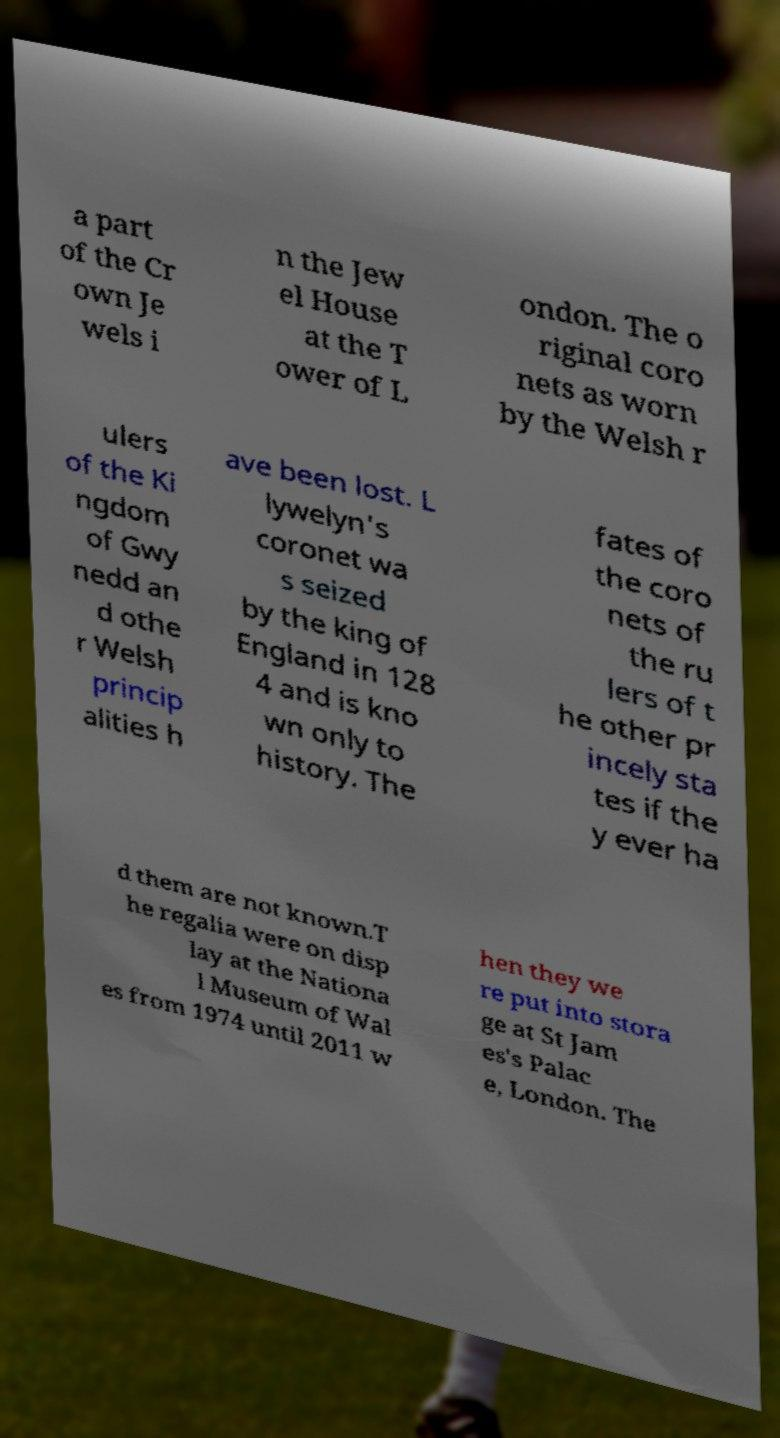There's text embedded in this image that I need extracted. Can you transcribe it verbatim? a part of the Cr own Je wels i n the Jew el House at the T ower of L ondon. The o riginal coro nets as worn by the Welsh r ulers of the Ki ngdom of Gwy nedd an d othe r Welsh princip alities h ave been lost. L lywelyn's coronet wa s seized by the king of England in 128 4 and is kno wn only to history. The fates of the coro nets of the ru lers of t he other pr incely sta tes if the y ever ha d them are not known.T he regalia were on disp lay at the Nationa l Museum of Wal es from 1974 until 2011 w hen they we re put into stora ge at St Jam es's Palac e, London. The 